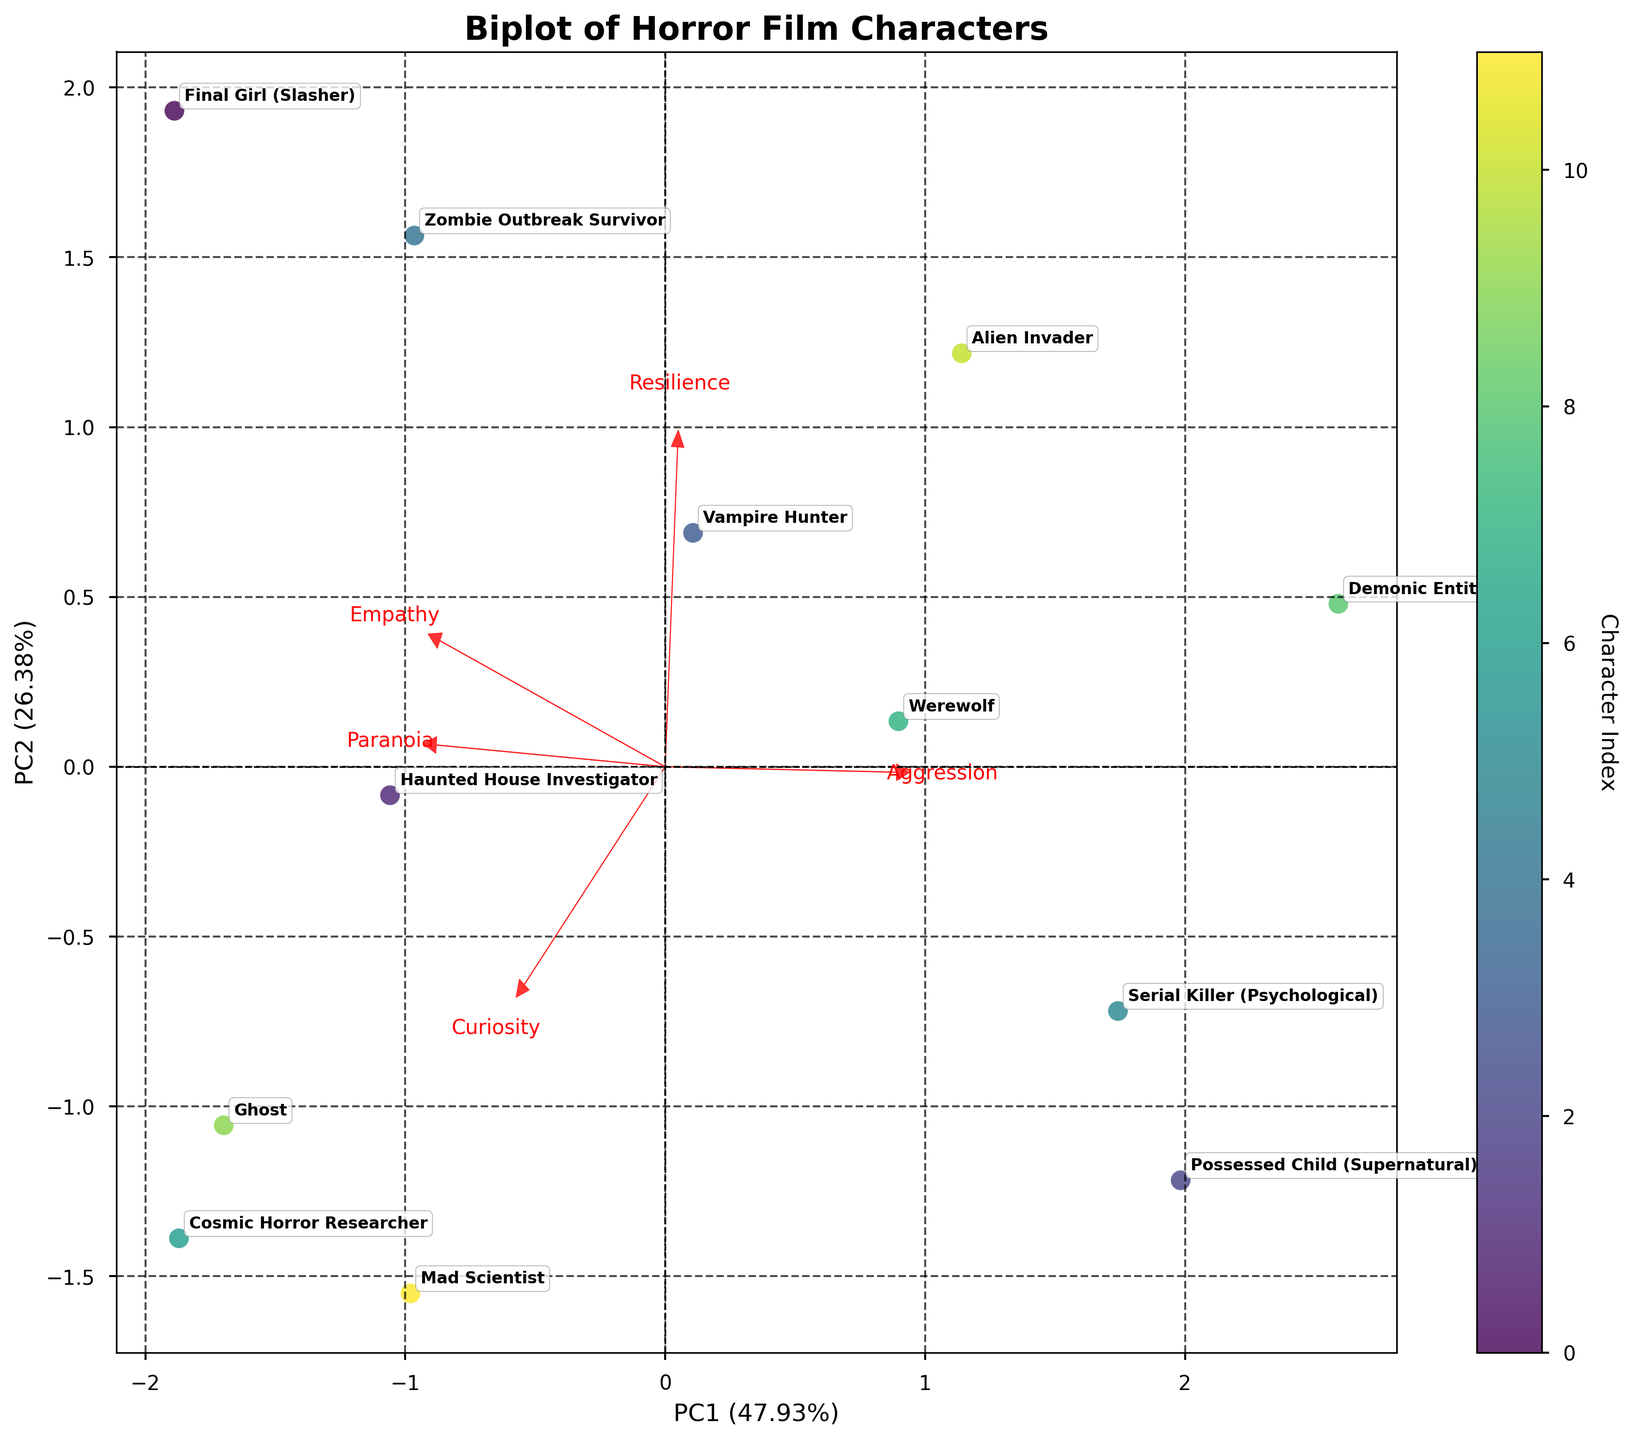How many characters are plotted in the figure? The scatter plot represents each character as a distinct point. By counting all labeled points, we can find the total number of characters displayed. The figure has 12 characters.
Answer: 12 Which character is positioned furthest along the x-axis? To determine this, look for the character whose label is furthest to the right or left on the x-axis. In this case, the label that is furthest along the x-axis is 'Mad Scientist'.
Answer: Mad Scientist What percentage of variance is explained by the first principal component (PC1)? The percentage of variance explained by each principal component is typically included in the axis labels. Look at the x-axis label to find the percentage for PC1. It is 34%.
Answer: 34% Which psychological trait has the longest loading vector? Loading vectors are represented by the red arrows originating from the origin. The length of these arrows indicates the importance of each psychological trait. 'Curiosity' seems to have the longest arrow.
Answer: Curiosity Are 'Final Girl (Slasher)' and 'Alien Invader' close to each other in the PCA space? Check the proximity of these two characters' labels in the plot. If they are close together, they are similar in the PCA-transformed space. 'Final Girl (Slasher)' and 'Alien Invader' are not close to each other.
Answer: No Which component has a higher explanatory power, PC1 or PC2? Compare the percentage of variance on the x-axis (PC1) and y-axis (PC2). The component with the higher percentage explains more variance. PC1 explains more variance at 34%, while PC2 explains 28%.
Answer: PC1 What character shows the highest empathy according to the figure? Emphasize the direction of the loading vector for 'Empathy', and observe which character is in its direction and furthest along it. 'Final Girl (Slasher)' has the highest empathy.
Answer: Final Girl (Slasher) Does 'Cosmic Horror Researcher' have high paranoia and curiosity? To assess this, check the character's proximity along the loading vectors for 'Paranoia' and 'Curiosity'. If it lies far out in the direction of both vectors, it has high values for these traits. 'Cosmic Horror Researcher' has high values for both.
Answer: Yes Which character seems to be most aggressive according to the biplot? Look at the loading vector for 'Aggression' and identify the character farthest in its direction. 'Demonic Entity' is the most aggressive.
Answer: Demonic Entity 